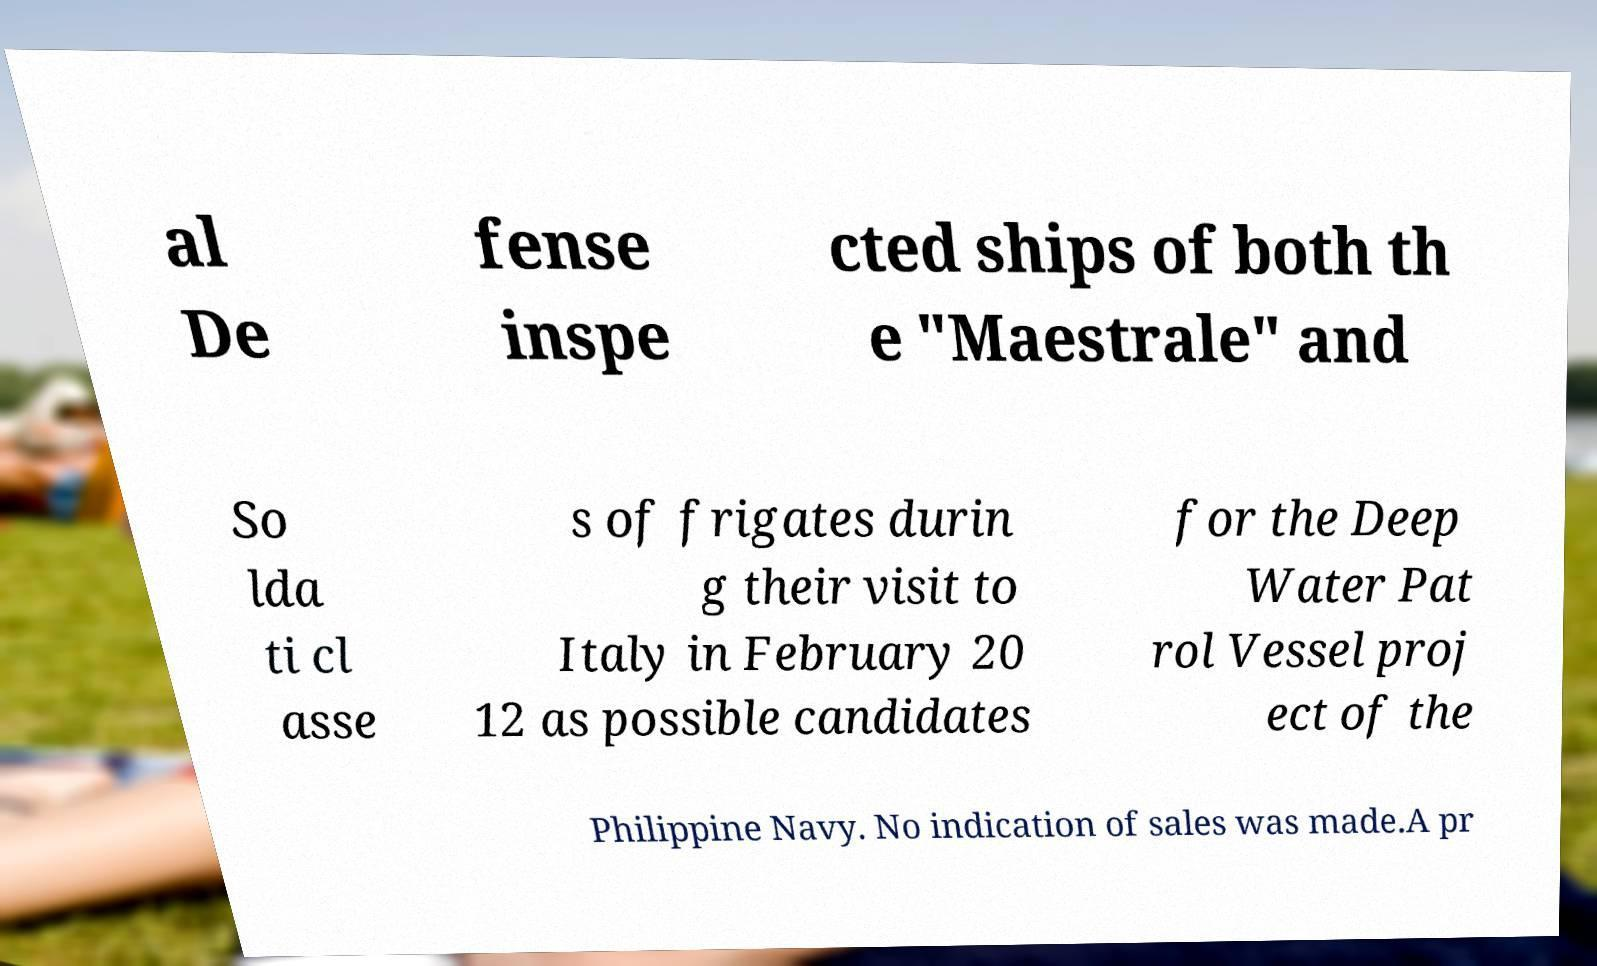For documentation purposes, I need the text within this image transcribed. Could you provide that? al De fense inspe cted ships of both th e "Maestrale" and So lda ti cl asse s of frigates durin g their visit to Italy in February 20 12 as possible candidates for the Deep Water Pat rol Vessel proj ect of the Philippine Navy. No indication of sales was made.A pr 